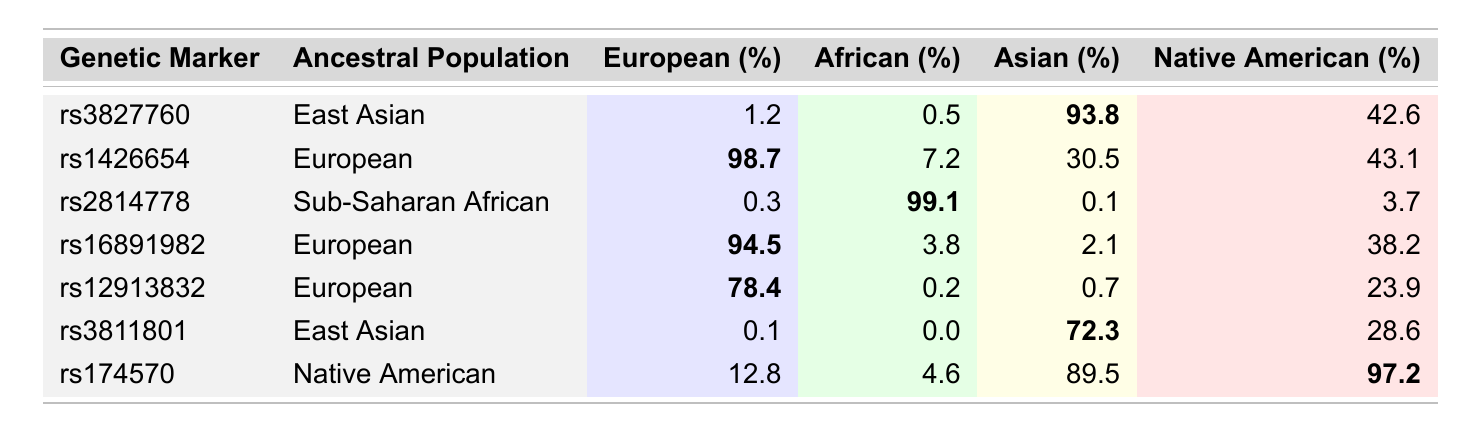What is the frequency of the genetic marker rs1426654 in the European population? The table shows that the frequency of the genetic marker rs1426654 in the European population is listed as 98.7%.
Answer: 98.7% Which genetic marker has the highest frequency in the Native American population? By looking at the Native American frequency column, the highest frequency is noted for the genetic marker rs174570, with a frequency of 97.2%.
Answer: rs174570 What is the European frequency of the genetic marker associated with the East Asian population? The table indicates that the genetic marker rs3827760, associated with East Asian ancestry, has a European frequency of 1.2%.
Answer: 1.2% What is the average frequency of the genetic markers among the African population? Adding the frequencies of the African population across all markers: 0.5 + 7.2 + 99.1 + 3.8 + 0.2 + 0.0 + 4.6 = 115.4. There are 7 markers, so the average is 115.4/7 ≈ 16.5%.
Answer: 16.5% Is the frequency of the genetic marker rs2814778 greater in the African or the European population? For rs2814778, the African frequency is 99.1% while the European frequency is only 0.3%, making the African frequency significantly greater.
Answer: Yes Which ancestral population has the lowest frequency for the genetic marker rs3811801? The frequencies for rs3811801 are: European 0.1%, African 0.0%, Asian 72.3%, Native American 28.6%. The lowest frequency is 0.0% in the African population.
Answer: African If you sum all frequencies of the genetic markers associated with the European population, what total do you get? Adding the frequencies for the European population: 98.7 + 94.5 + 78.4 = 271.6% (considering this is multiple markers, this sum reflects their prevalence across individuals).
Answer: 271.6% Is there any genetic marker that shows a frequency higher than 90% in the Asian population? Reviewing the table, the genetic markers rs3827760 and rs174570 both have frequencies of 93.8% and 89.5%, respectively, indicating that rs3827760 is the only one exceeding 90% in the Asian population.
Answer: Yes Which ancestral population shows the highest diversity in genetic marker frequencies? The frequencies for European markers show a wide range from 0.3% for rs2814778 to 98.7% for rs1426654. Their variability indicates that Europeans show higher diversity compared to other populations that tend to have more markers clustered around similar percentages.
Answer: European How much more common is the Sub-Saharan African marker rs2814778 in comparison to the Asian frequency of the same marker? The frequency for rs2814778 in Sub-Saharan African is 99.1% whereas in Asia it is only 0.1%. The difference is 99.1% - 0.1% = 99.0%. Thus, it is 99.0% more common in Sub-Saharan Africans.
Answer: 99.0% 